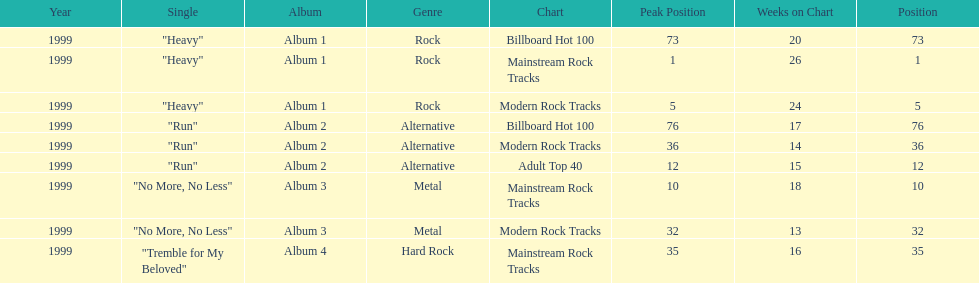How many singles from "dosage" appeared on the modern rock tracks charts? 3. 